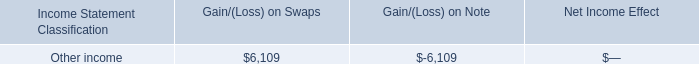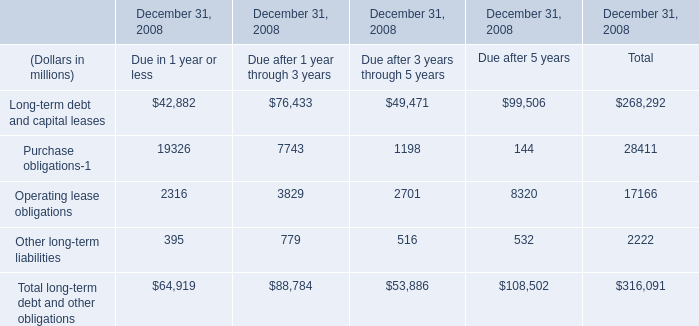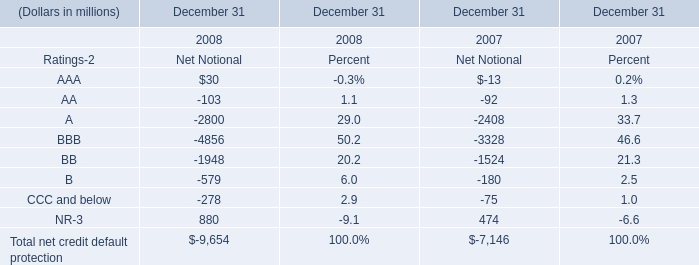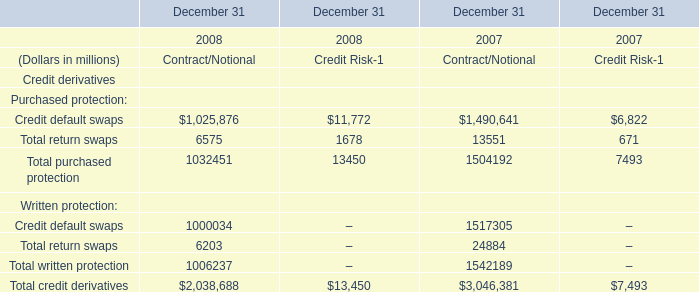What's the total amount of the credit derivatives in the years where Total purchased protection greater than 1500000? (in million) 
Computations: (3046381 + 7493)
Answer: 3053874.0. 